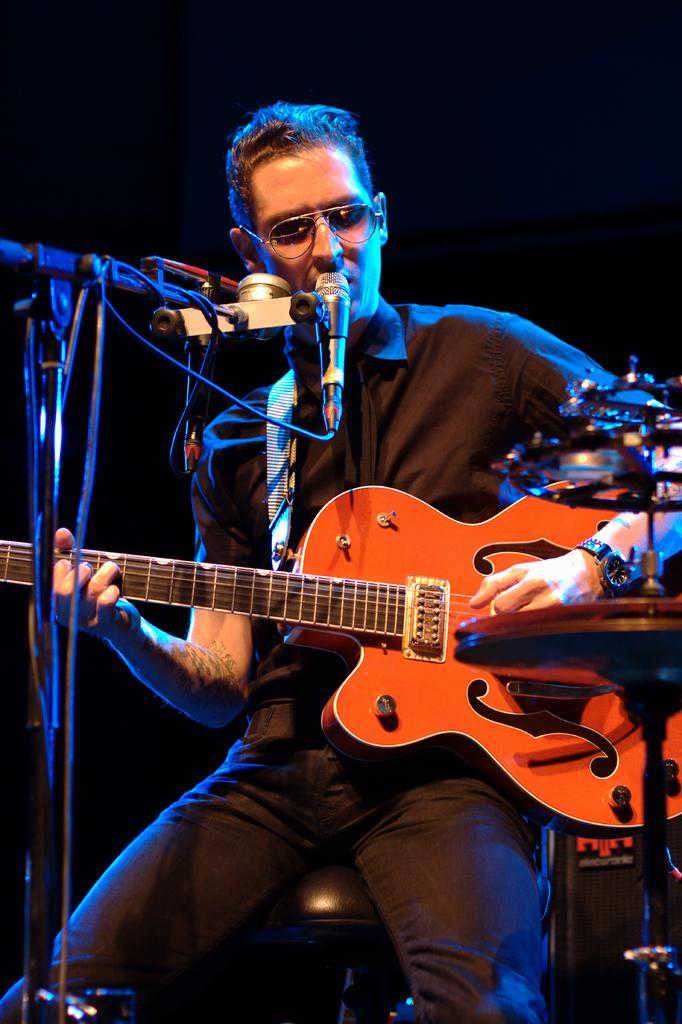What is the main subject of the image? There is a person in the image. What is the person holding in the image? The person is holding a guitar and a microphone in front of them. What type of parcel is being delivered to the person in the image? There is no parcel being delivered to the person in the image. What request is the person making while holding the microphone? The image does not provide any information about a request being made by the person holding the microphone. 